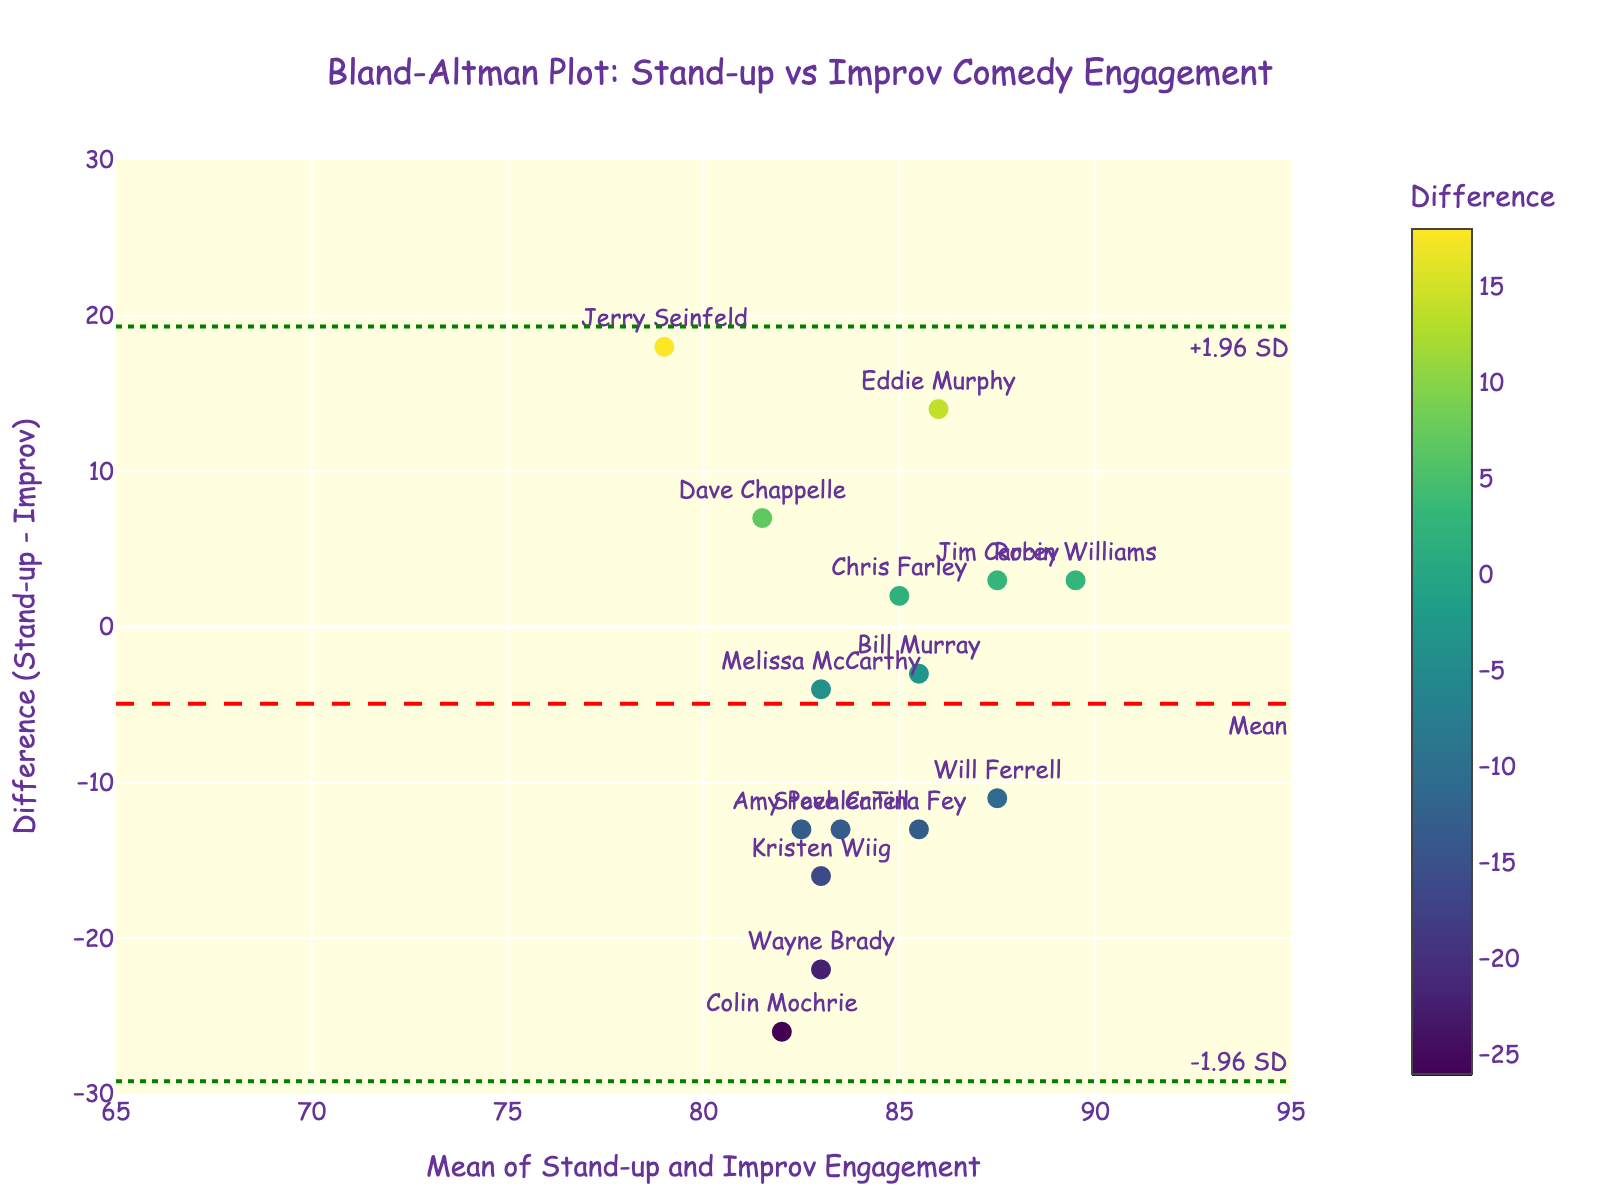How many comedians are represented in the plot? Count the number of unique comedians listed in the data. There are 15 comedians in total.
Answer: 15 What is the mean engagement difference between Stand-up and Improv performances? The plot has a dashed red line representing the mean difference, which is at y = -3.13.
Answer: -3.13 What are the limits of agreement represented in the plot? The plot has dotted green lines representing the limits of agreement at y = 1.96 standard deviations above and below the mean difference. The limits are approximately y = 21.83 and y = -28.09.
Answer: 21.83 and -28.09 Which comedian shows the highest positive difference in engagement between Stand-up and Improv? Look at the scatter plot and find the highest point on the positive y-axis for differences. Jerry Seinfeld has the highest positive difference.
Answer: Jerry Seinfeld Why are the mean and difference plotted instead of individual engagement levels? The Bland-Altman plot uses the average of the two measures on the x-axis and the difference between the measures on the y-axis to visualize the agreement between two different methods. This helps to see how much one method overestimates or underestimates compared to the other across the range of measurements.
Answer: To visualize agreement between the two performances Which comedians have a negative difference in engagement? Look at the scatter points below the zero line on the y-axis. Comedians such as Dave Chappelle, Eddie Murphy, and Jerry Seinfeld have negative differences.
Answer: Dave Chappelle, Eddie Murphy, Jerry Seinfeld What does a point located above the mean difference line indicate about that comedian's engagement levels? A point above the mean difference line indicates that the comedian's Stand-up engagement is higher than their Improv engagement.
Answer: Stand-up higher than Improv Which comedian's engagement levels are closest to the mean difference? Look for the point nearest to the dashed red line in the plot. Robin Williams' engagement levels are closest to the mean difference.
Answer: Robin Williams How do the two comedians, Wayne Brady and Colin Mochrie, compare in terms of their difference and mean engagement levels? Wayne Brady has a mean engagement level of 83 and a difference of -22, while Colin Mochrie has a mean engagement level of 82 and a difference of -26. Both have high negative differences and similar mean engagement levels.
Answer: High negative differences, similar mean levels 